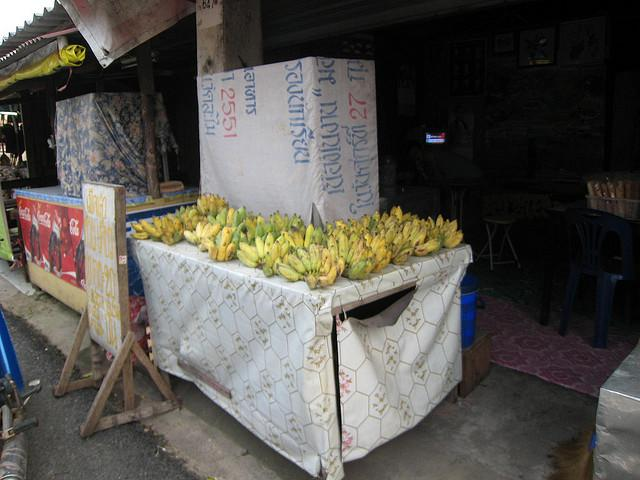What country produces a large number of these yellow food items? india 